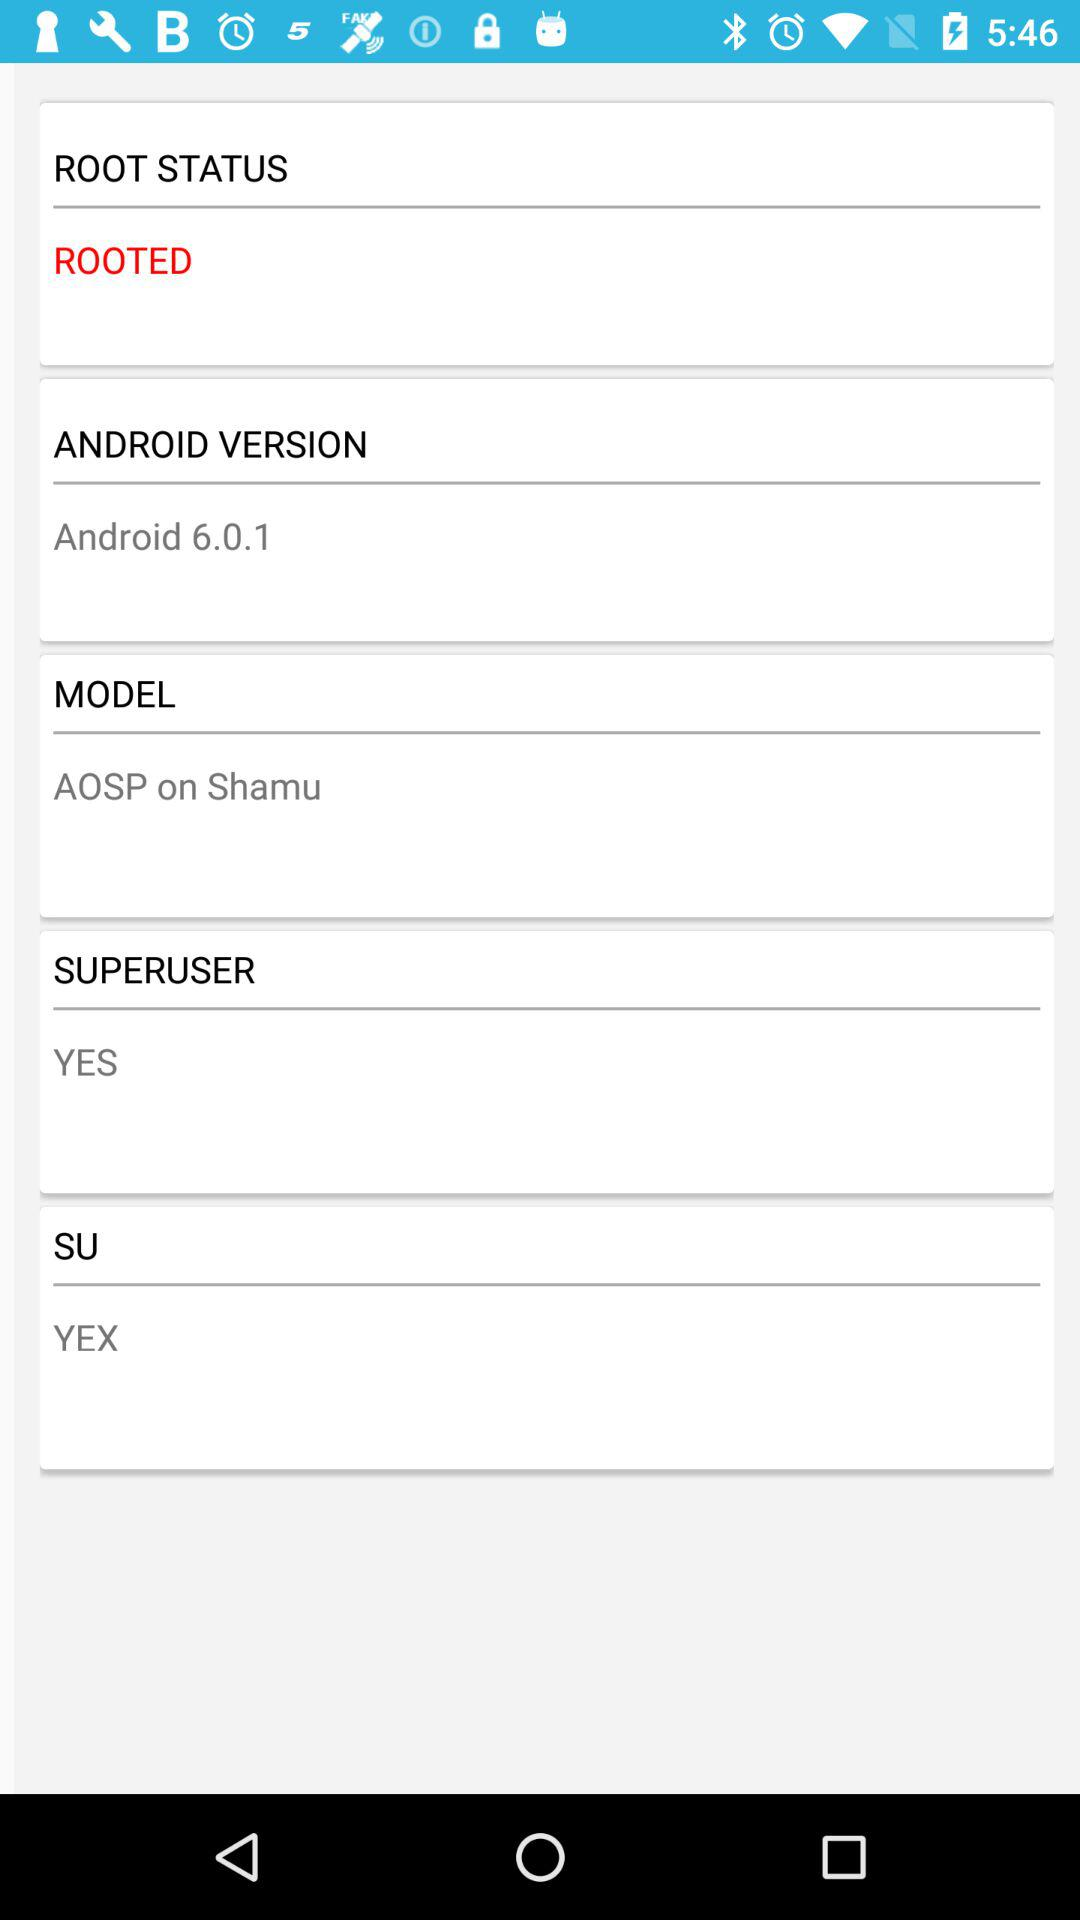Which version of Android is it? The version of Android is 6.0.1. 